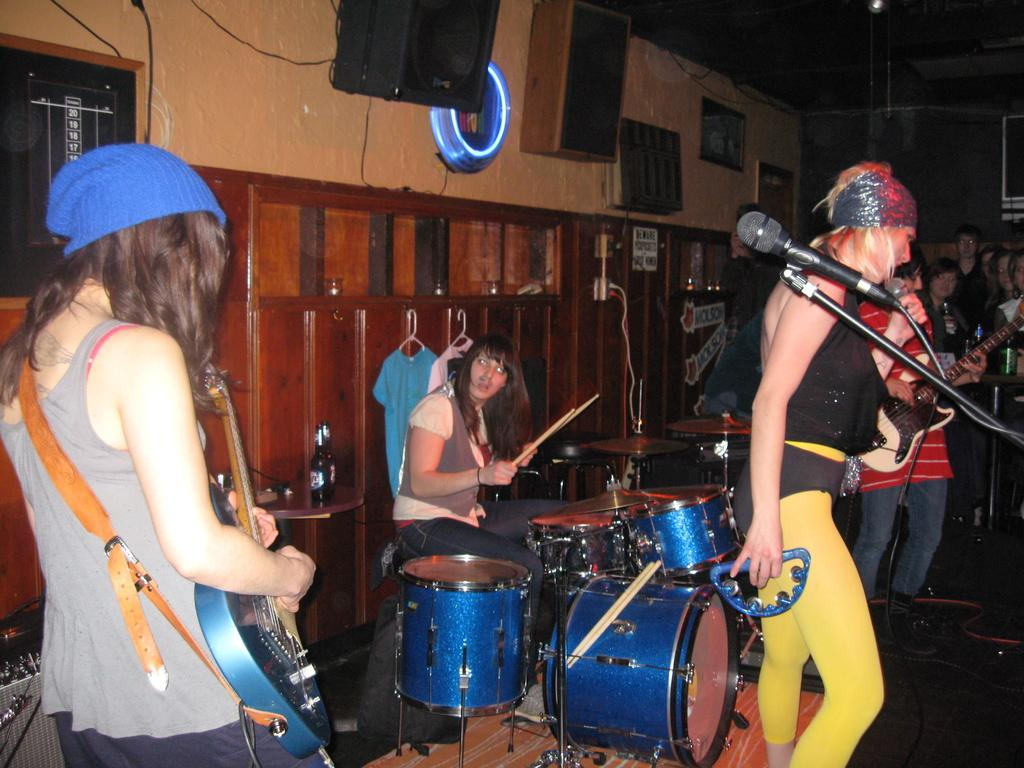How many people are in the image? There is a group of people in the image. What are some of the people in the image doing? Three persons are holding musical instruments, and one person is playing a musical instrument. What can be seen in the background of the image? There is a wall in the background of the image. What type of surface is visible in the image? The image shows a floor. What type of ocean can be seen in the image? There is no ocean present in the image. What sound is produced by the musical instruments in the image? The image is static, so no sound can be heard or inferred from it. 